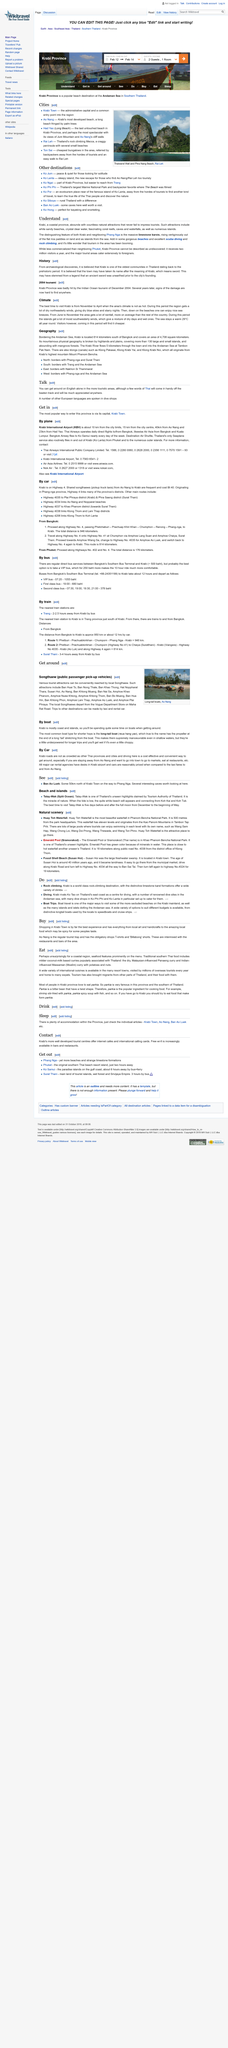Point out several critical features in this image. The best place to enter the province by plane is through Krabi International Airport, as it offers the most convenient and direct route for travelers. At Krabi Airport, a variety of desks for major car rental agencies can be found, providing travelers with convenient options for renting vehicles during their stay. The best time to visit Talay-Wak is during the five days leading up to and after the full moon from December to the beginning of May. Ao Nang is Krabi's most developed beach. Krabi is less commercialized than Phuket. 